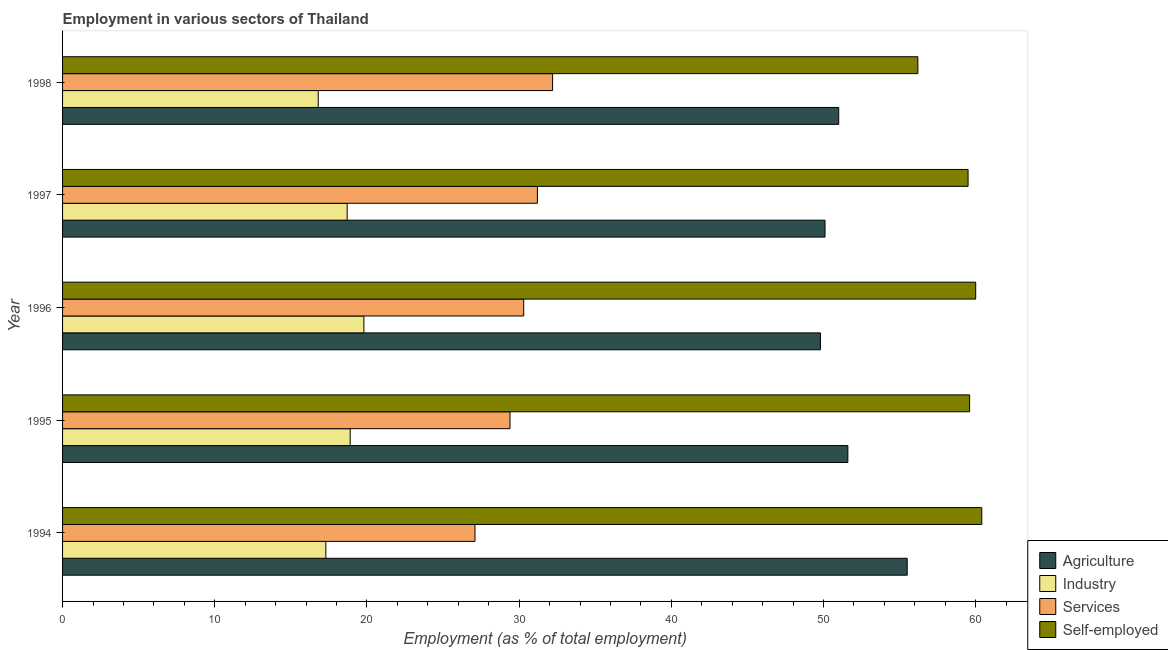Are the number of bars per tick equal to the number of legend labels?
Your answer should be very brief. Yes. Are the number of bars on each tick of the Y-axis equal?
Provide a short and direct response. Yes. How many bars are there on the 2nd tick from the top?
Your answer should be very brief. 4. How many bars are there on the 4th tick from the bottom?
Give a very brief answer. 4. What is the percentage of workers in agriculture in 1996?
Provide a short and direct response. 49.8. Across all years, what is the maximum percentage of self employed workers?
Offer a terse response. 60.4. Across all years, what is the minimum percentage of self employed workers?
Your answer should be very brief. 56.2. In which year was the percentage of workers in industry maximum?
Offer a very short reply. 1996. What is the total percentage of workers in services in the graph?
Offer a terse response. 150.2. What is the difference between the percentage of workers in agriculture in 1994 and that in 1995?
Provide a short and direct response. 3.9. What is the difference between the percentage of workers in agriculture in 1995 and the percentage of self employed workers in 1998?
Your response must be concise. -4.6. In the year 1994, what is the difference between the percentage of workers in agriculture and percentage of self employed workers?
Keep it short and to the point. -4.9. Is the percentage of self employed workers in 1996 less than that in 1998?
Your answer should be very brief. No. What is the difference between the highest and the second highest percentage of workers in agriculture?
Ensure brevity in your answer.  3.9. What is the difference between the highest and the lowest percentage of workers in agriculture?
Offer a terse response. 5.7. In how many years, is the percentage of workers in industry greater than the average percentage of workers in industry taken over all years?
Make the answer very short. 3. Is it the case that in every year, the sum of the percentage of workers in agriculture and percentage of workers in industry is greater than the sum of percentage of self employed workers and percentage of workers in services?
Your answer should be very brief. No. What does the 3rd bar from the top in 1995 represents?
Provide a short and direct response. Industry. What does the 4th bar from the bottom in 1998 represents?
Provide a short and direct response. Self-employed. How many bars are there?
Keep it short and to the point. 20. How many years are there in the graph?
Provide a succinct answer. 5. What is the difference between two consecutive major ticks on the X-axis?
Your answer should be very brief. 10. Are the values on the major ticks of X-axis written in scientific E-notation?
Offer a very short reply. No. Does the graph contain any zero values?
Your answer should be compact. No. Where does the legend appear in the graph?
Your answer should be compact. Bottom right. How many legend labels are there?
Keep it short and to the point. 4. How are the legend labels stacked?
Your answer should be very brief. Vertical. What is the title of the graph?
Offer a terse response. Employment in various sectors of Thailand. Does "Other greenhouse gases" appear as one of the legend labels in the graph?
Your response must be concise. No. What is the label or title of the X-axis?
Your response must be concise. Employment (as % of total employment). What is the label or title of the Y-axis?
Your answer should be compact. Year. What is the Employment (as % of total employment) of Agriculture in 1994?
Your answer should be compact. 55.5. What is the Employment (as % of total employment) of Industry in 1994?
Your answer should be compact. 17.3. What is the Employment (as % of total employment) of Services in 1994?
Your response must be concise. 27.1. What is the Employment (as % of total employment) in Self-employed in 1994?
Your answer should be compact. 60.4. What is the Employment (as % of total employment) in Agriculture in 1995?
Your answer should be very brief. 51.6. What is the Employment (as % of total employment) of Industry in 1995?
Your answer should be compact. 18.9. What is the Employment (as % of total employment) of Services in 1995?
Provide a succinct answer. 29.4. What is the Employment (as % of total employment) in Self-employed in 1995?
Keep it short and to the point. 59.6. What is the Employment (as % of total employment) in Agriculture in 1996?
Keep it short and to the point. 49.8. What is the Employment (as % of total employment) in Industry in 1996?
Provide a succinct answer. 19.8. What is the Employment (as % of total employment) in Services in 1996?
Ensure brevity in your answer.  30.3. What is the Employment (as % of total employment) of Self-employed in 1996?
Your answer should be very brief. 60. What is the Employment (as % of total employment) in Agriculture in 1997?
Provide a short and direct response. 50.1. What is the Employment (as % of total employment) in Industry in 1997?
Make the answer very short. 18.7. What is the Employment (as % of total employment) of Services in 1997?
Ensure brevity in your answer.  31.2. What is the Employment (as % of total employment) of Self-employed in 1997?
Your answer should be compact. 59.5. What is the Employment (as % of total employment) in Agriculture in 1998?
Your response must be concise. 51. What is the Employment (as % of total employment) in Industry in 1998?
Provide a short and direct response. 16.8. What is the Employment (as % of total employment) in Services in 1998?
Ensure brevity in your answer.  32.2. What is the Employment (as % of total employment) in Self-employed in 1998?
Ensure brevity in your answer.  56.2. Across all years, what is the maximum Employment (as % of total employment) in Agriculture?
Give a very brief answer. 55.5. Across all years, what is the maximum Employment (as % of total employment) in Industry?
Ensure brevity in your answer.  19.8. Across all years, what is the maximum Employment (as % of total employment) in Services?
Offer a terse response. 32.2. Across all years, what is the maximum Employment (as % of total employment) of Self-employed?
Give a very brief answer. 60.4. Across all years, what is the minimum Employment (as % of total employment) in Agriculture?
Provide a succinct answer. 49.8. Across all years, what is the minimum Employment (as % of total employment) in Industry?
Your answer should be very brief. 16.8. Across all years, what is the minimum Employment (as % of total employment) of Services?
Make the answer very short. 27.1. Across all years, what is the minimum Employment (as % of total employment) in Self-employed?
Your response must be concise. 56.2. What is the total Employment (as % of total employment) in Agriculture in the graph?
Your response must be concise. 258. What is the total Employment (as % of total employment) of Industry in the graph?
Give a very brief answer. 91.5. What is the total Employment (as % of total employment) of Services in the graph?
Give a very brief answer. 150.2. What is the total Employment (as % of total employment) of Self-employed in the graph?
Provide a short and direct response. 295.7. What is the difference between the Employment (as % of total employment) in Industry in 1994 and that in 1995?
Provide a short and direct response. -1.6. What is the difference between the Employment (as % of total employment) in Agriculture in 1994 and that in 1996?
Your answer should be compact. 5.7. What is the difference between the Employment (as % of total employment) of Industry in 1994 and that in 1996?
Your response must be concise. -2.5. What is the difference between the Employment (as % of total employment) in Industry in 1994 and that in 1997?
Give a very brief answer. -1.4. What is the difference between the Employment (as % of total employment) of Agriculture in 1994 and that in 1998?
Make the answer very short. 4.5. What is the difference between the Employment (as % of total employment) of Self-employed in 1994 and that in 1998?
Your answer should be very brief. 4.2. What is the difference between the Employment (as % of total employment) of Services in 1995 and that in 1996?
Make the answer very short. -0.9. What is the difference between the Employment (as % of total employment) in Self-employed in 1995 and that in 1996?
Provide a short and direct response. -0.4. What is the difference between the Employment (as % of total employment) of Agriculture in 1995 and that in 1997?
Provide a succinct answer. 1.5. What is the difference between the Employment (as % of total employment) of Services in 1995 and that in 1997?
Offer a terse response. -1.8. What is the difference between the Employment (as % of total employment) of Industry in 1996 and that in 1997?
Ensure brevity in your answer.  1.1. What is the difference between the Employment (as % of total employment) in Self-employed in 1996 and that in 1997?
Give a very brief answer. 0.5. What is the difference between the Employment (as % of total employment) in Agriculture in 1996 and that in 1998?
Offer a very short reply. -1.2. What is the difference between the Employment (as % of total employment) in Self-employed in 1996 and that in 1998?
Offer a terse response. 3.8. What is the difference between the Employment (as % of total employment) in Agriculture in 1997 and that in 1998?
Give a very brief answer. -0.9. What is the difference between the Employment (as % of total employment) in Industry in 1997 and that in 1998?
Keep it short and to the point. 1.9. What is the difference between the Employment (as % of total employment) of Services in 1997 and that in 1998?
Keep it short and to the point. -1. What is the difference between the Employment (as % of total employment) of Self-employed in 1997 and that in 1998?
Offer a very short reply. 3.3. What is the difference between the Employment (as % of total employment) of Agriculture in 1994 and the Employment (as % of total employment) of Industry in 1995?
Ensure brevity in your answer.  36.6. What is the difference between the Employment (as % of total employment) of Agriculture in 1994 and the Employment (as % of total employment) of Services in 1995?
Make the answer very short. 26.1. What is the difference between the Employment (as % of total employment) of Agriculture in 1994 and the Employment (as % of total employment) of Self-employed in 1995?
Your response must be concise. -4.1. What is the difference between the Employment (as % of total employment) in Industry in 1994 and the Employment (as % of total employment) in Self-employed in 1995?
Provide a short and direct response. -42.3. What is the difference between the Employment (as % of total employment) in Services in 1994 and the Employment (as % of total employment) in Self-employed in 1995?
Make the answer very short. -32.5. What is the difference between the Employment (as % of total employment) of Agriculture in 1994 and the Employment (as % of total employment) of Industry in 1996?
Ensure brevity in your answer.  35.7. What is the difference between the Employment (as % of total employment) of Agriculture in 1994 and the Employment (as % of total employment) of Services in 1996?
Keep it short and to the point. 25.2. What is the difference between the Employment (as % of total employment) of Industry in 1994 and the Employment (as % of total employment) of Self-employed in 1996?
Make the answer very short. -42.7. What is the difference between the Employment (as % of total employment) in Services in 1994 and the Employment (as % of total employment) in Self-employed in 1996?
Offer a very short reply. -32.9. What is the difference between the Employment (as % of total employment) in Agriculture in 1994 and the Employment (as % of total employment) in Industry in 1997?
Your answer should be compact. 36.8. What is the difference between the Employment (as % of total employment) in Agriculture in 1994 and the Employment (as % of total employment) in Services in 1997?
Offer a very short reply. 24.3. What is the difference between the Employment (as % of total employment) in Industry in 1994 and the Employment (as % of total employment) in Self-employed in 1997?
Provide a short and direct response. -42.2. What is the difference between the Employment (as % of total employment) in Services in 1994 and the Employment (as % of total employment) in Self-employed in 1997?
Your answer should be very brief. -32.4. What is the difference between the Employment (as % of total employment) of Agriculture in 1994 and the Employment (as % of total employment) of Industry in 1998?
Keep it short and to the point. 38.7. What is the difference between the Employment (as % of total employment) of Agriculture in 1994 and the Employment (as % of total employment) of Services in 1998?
Provide a succinct answer. 23.3. What is the difference between the Employment (as % of total employment) in Agriculture in 1994 and the Employment (as % of total employment) in Self-employed in 1998?
Offer a terse response. -0.7. What is the difference between the Employment (as % of total employment) in Industry in 1994 and the Employment (as % of total employment) in Services in 1998?
Make the answer very short. -14.9. What is the difference between the Employment (as % of total employment) of Industry in 1994 and the Employment (as % of total employment) of Self-employed in 1998?
Your answer should be compact. -38.9. What is the difference between the Employment (as % of total employment) in Services in 1994 and the Employment (as % of total employment) in Self-employed in 1998?
Provide a short and direct response. -29.1. What is the difference between the Employment (as % of total employment) of Agriculture in 1995 and the Employment (as % of total employment) of Industry in 1996?
Make the answer very short. 31.8. What is the difference between the Employment (as % of total employment) of Agriculture in 1995 and the Employment (as % of total employment) of Services in 1996?
Your answer should be very brief. 21.3. What is the difference between the Employment (as % of total employment) in Agriculture in 1995 and the Employment (as % of total employment) in Self-employed in 1996?
Your answer should be compact. -8.4. What is the difference between the Employment (as % of total employment) in Industry in 1995 and the Employment (as % of total employment) in Self-employed in 1996?
Offer a terse response. -41.1. What is the difference between the Employment (as % of total employment) in Services in 1995 and the Employment (as % of total employment) in Self-employed in 1996?
Offer a terse response. -30.6. What is the difference between the Employment (as % of total employment) in Agriculture in 1995 and the Employment (as % of total employment) in Industry in 1997?
Ensure brevity in your answer.  32.9. What is the difference between the Employment (as % of total employment) in Agriculture in 1995 and the Employment (as % of total employment) in Services in 1997?
Offer a terse response. 20.4. What is the difference between the Employment (as % of total employment) of Agriculture in 1995 and the Employment (as % of total employment) of Self-employed in 1997?
Your response must be concise. -7.9. What is the difference between the Employment (as % of total employment) in Industry in 1995 and the Employment (as % of total employment) in Self-employed in 1997?
Your answer should be very brief. -40.6. What is the difference between the Employment (as % of total employment) in Services in 1995 and the Employment (as % of total employment) in Self-employed in 1997?
Ensure brevity in your answer.  -30.1. What is the difference between the Employment (as % of total employment) of Agriculture in 1995 and the Employment (as % of total employment) of Industry in 1998?
Ensure brevity in your answer.  34.8. What is the difference between the Employment (as % of total employment) in Agriculture in 1995 and the Employment (as % of total employment) in Services in 1998?
Offer a terse response. 19.4. What is the difference between the Employment (as % of total employment) in Industry in 1995 and the Employment (as % of total employment) in Self-employed in 1998?
Offer a very short reply. -37.3. What is the difference between the Employment (as % of total employment) of Services in 1995 and the Employment (as % of total employment) of Self-employed in 1998?
Offer a terse response. -26.8. What is the difference between the Employment (as % of total employment) of Agriculture in 1996 and the Employment (as % of total employment) of Industry in 1997?
Your answer should be very brief. 31.1. What is the difference between the Employment (as % of total employment) in Agriculture in 1996 and the Employment (as % of total employment) in Services in 1997?
Keep it short and to the point. 18.6. What is the difference between the Employment (as % of total employment) in Agriculture in 1996 and the Employment (as % of total employment) in Self-employed in 1997?
Your response must be concise. -9.7. What is the difference between the Employment (as % of total employment) in Industry in 1996 and the Employment (as % of total employment) in Services in 1997?
Make the answer very short. -11.4. What is the difference between the Employment (as % of total employment) of Industry in 1996 and the Employment (as % of total employment) of Self-employed in 1997?
Provide a short and direct response. -39.7. What is the difference between the Employment (as % of total employment) in Services in 1996 and the Employment (as % of total employment) in Self-employed in 1997?
Your response must be concise. -29.2. What is the difference between the Employment (as % of total employment) of Agriculture in 1996 and the Employment (as % of total employment) of Industry in 1998?
Make the answer very short. 33. What is the difference between the Employment (as % of total employment) of Industry in 1996 and the Employment (as % of total employment) of Self-employed in 1998?
Make the answer very short. -36.4. What is the difference between the Employment (as % of total employment) in Services in 1996 and the Employment (as % of total employment) in Self-employed in 1998?
Your answer should be compact. -25.9. What is the difference between the Employment (as % of total employment) in Agriculture in 1997 and the Employment (as % of total employment) in Industry in 1998?
Make the answer very short. 33.3. What is the difference between the Employment (as % of total employment) of Industry in 1997 and the Employment (as % of total employment) of Services in 1998?
Offer a very short reply. -13.5. What is the difference between the Employment (as % of total employment) of Industry in 1997 and the Employment (as % of total employment) of Self-employed in 1998?
Your answer should be compact. -37.5. What is the difference between the Employment (as % of total employment) in Services in 1997 and the Employment (as % of total employment) in Self-employed in 1998?
Provide a short and direct response. -25. What is the average Employment (as % of total employment) of Agriculture per year?
Offer a very short reply. 51.6. What is the average Employment (as % of total employment) in Industry per year?
Offer a terse response. 18.3. What is the average Employment (as % of total employment) in Services per year?
Keep it short and to the point. 30.04. What is the average Employment (as % of total employment) of Self-employed per year?
Your answer should be compact. 59.14. In the year 1994, what is the difference between the Employment (as % of total employment) of Agriculture and Employment (as % of total employment) of Industry?
Provide a succinct answer. 38.2. In the year 1994, what is the difference between the Employment (as % of total employment) of Agriculture and Employment (as % of total employment) of Services?
Provide a short and direct response. 28.4. In the year 1994, what is the difference between the Employment (as % of total employment) in Agriculture and Employment (as % of total employment) in Self-employed?
Give a very brief answer. -4.9. In the year 1994, what is the difference between the Employment (as % of total employment) in Industry and Employment (as % of total employment) in Self-employed?
Ensure brevity in your answer.  -43.1. In the year 1994, what is the difference between the Employment (as % of total employment) in Services and Employment (as % of total employment) in Self-employed?
Your response must be concise. -33.3. In the year 1995, what is the difference between the Employment (as % of total employment) of Agriculture and Employment (as % of total employment) of Industry?
Offer a terse response. 32.7. In the year 1995, what is the difference between the Employment (as % of total employment) of Agriculture and Employment (as % of total employment) of Self-employed?
Give a very brief answer. -8. In the year 1995, what is the difference between the Employment (as % of total employment) of Industry and Employment (as % of total employment) of Services?
Your response must be concise. -10.5. In the year 1995, what is the difference between the Employment (as % of total employment) of Industry and Employment (as % of total employment) of Self-employed?
Your answer should be very brief. -40.7. In the year 1995, what is the difference between the Employment (as % of total employment) in Services and Employment (as % of total employment) in Self-employed?
Ensure brevity in your answer.  -30.2. In the year 1996, what is the difference between the Employment (as % of total employment) of Agriculture and Employment (as % of total employment) of Services?
Give a very brief answer. 19.5. In the year 1996, what is the difference between the Employment (as % of total employment) in Industry and Employment (as % of total employment) in Services?
Make the answer very short. -10.5. In the year 1996, what is the difference between the Employment (as % of total employment) of Industry and Employment (as % of total employment) of Self-employed?
Provide a succinct answer. -40.2. In the year 1996, what is the difference between the Employment (as % of total employment) in Services and Employment (as % of total employment) in Self-employed?
Your response must be concise. -29.7. In the year 1997, what is the difference between the Employment (as % of total employment) of Agriculture and Employment (as % of total employment) of Industry?
Your response must be concise. 31.4. In the year 1997, what is the difference between the Employment (as % of total employment) in Industry and Employment (as % of total employment) in Services?
Offer a very short reply. -12.5. In the year 1997, what is the difference between the Employment (as % of total employment) of Industry and Employment (as % of total employment) of Self-employed?
Ensure brevity in your answer.  -40.8. In the year 1997, what is the difference between the Employment (as % of total employment) in Services and Employment (as % of total employment) in Self-employed?
Keep it short and to the point. -28.3. In the year 1998, what is the difference between the Employment (as % of total employment) in Agriculture and Employment (as % of total employment) in Industry?
Offer a terse response. 34.2. In the year 1998, what is the difference between the Employment (as % of total employment) in Agriculture and Employment (as % of total employment) in Services?
Offer a very short reply. 18.8. In the year 1998, what is the difference between the Employment (as % of total employment) in Agriculture and Employment (as % of total employment) in Self-employed?
Offer a terse response. -5.2. In the year 1998, what is the difference between the Employment (as % of total employment) in Industry and Employment (as % of total employment) in Services?
Keep it short and to the point. -15.4. In the year 1998, what is the difference between the Employment (as % of total employment) of Industry and Employment (as % of total employment) of Self-employed?
Keep it short and to the point. -39.4. What is the ratio of the Employment (as % of total employment) in Agriculture in 1994 to that in 1995?
Offer a terse response. 1.08. What is the ratio of the Employment (as % of total employment) of Industry in 1994 to that in 1995?
Offer a very short reply. 0.92. What is the ratio of the Employment (as % of total employment) in Services in 1994 to that in 1995?
Make the answer very short. 0.92. What is the ratio of the Employment (as % of total employment) of Self-employed in 1994 to that in 1995?
Offer a very short reply. 1.01. What is the ratio of the Employment (as % of total employment) of Agriculture in 1994 to that in 1996?
Ensure brevity in your answer.  1.11. What is the ratio of the Employment (as % of total employment) in Industry in 1994 to that in 1996?
Your response must be concise. 0.87. What is the ratio of the Employment (as % of total employment) in Services in 1994 to that in 1996?
Keep it short and to the point. 0.89. What is the ratio of the Employment (as % of total employment) in Self-employed in 1994 to that in 1996?
Make the answer very short. 1.01. What is the ratio of the Employment (as % of total employment) of Agriculture in 1994 to that in 1997?
Ensure brevity in your answer.  1.11. What is the ratio of the Employment (as % of total employment) of Industry in 1994 to that in 1997?
Provide a short and direct response. 0.93. What is the ratio of the Employment (as % of total employment) of Services in 1994 to that in 1997?
Offer a terse response. 0.87. What is the ratio of the Employment (as % of total employment) in Self-employed in 1994 to that in 1997?
Provide a succinct answer. 1.02. What is the ratio of the Employment (as % of total employment) of Agriculture in 1994 to that in 1998?
Your response must be concise. 1.09. What is the ratio of the Employment (as % of total employment) in Industry in 1994 to that in 1998?
Keep it short and to the point. 1.03. What is the ratio of the Employment (as % of total employment) in Services in 1994 to that in 1998?
Keep it short and to the point. 0.84. What is the ratio of the Employment (as % of total employment) in Self-employed in 1994 to that in 1998?
Provide a short and direct response. 1.07. What is the ratio of the Employment (as % of total employment) of Agriculture in 1995 to that in 1996?
Provide a short and direct response. 1.04. What is the ratio of the Employment (as % of total employment) in Industry in 1995 to that in 1996?
Give a very brief answer. 0.95. What is the ratio of the Employment (as % of total employment) in Services in 1995 to that in 1996?
Your answer should be compact. 0.97. What is the ratio of the Employment (as % of total employment) in Self-employed in 1995 to that in 1996?
Ensure brevity in your answer.  0.99. What is the ratio of the Employment (as % of total employment) in Agriculture in 1995 to that in 1997?
Offer a terse response. 1.03. What is the ratio of the Employment (as % of total employment) in Industry in 1995 to that in 1997?
Provide a short and direct response. 1.01. What is the ratio of the Employment (as % of total employment) of Services in 1995 to that in 1997?
Ensure brevity in your answer.  0.94. What is the ratio of the Employment (as % of total employment) in Agriculture in 1995 to that in 1998?
Your answer should be compact. 1.01. What is the ratio of the Employment (as % of total employment) of Industry in 1995 to that in 1998?
Your response must be concise. 1.12. What is the ratio of the Employment (as % of total employment) in Services in 1995 to that in 1998?
Offer a very short reply. 0.91. What is the ratio of the Employment (as % of total employment) in Self-employed in 1995 to that in 1998?
Provide a short and direct response. 1.06. What is the ratio of the Employment (as % of total employment) of Agriculture in 1996 to that in 1997?
Keep it short and to the point. 0.99. What is the ratio of the Employment (as % of total employment) in Industry in 1996 to that in 1997?
Give a very brief answer. 1.06. What is the ratio of the Employment (as % of total employment) of Services in 1996 to that in 1997?
Provide a succinct answer. 0.97. What is the ratio of the Employment (as % of total employment) in Self-employed in 1996 to that in 1997?
Make the answer very short. 1.01. What is the ratio of the Employment (as % of total employment) in Agriculture in 1996 to that in 1998?
Provide a succinct answer. 0.98. What is the ratio of the Employment (as % of total employment) of Industry in 1996 to that in 1998?
Your response must be concise. 1.18. What is the ratio of the Employment (as % of total employment) in Services in 1996 to that in 1998?
Provide a short and direct response. 0.94. What is the ratio of the Employment (as % of total employment) of Self-employed in 1996 to that in 1998?
Your answer should be very brief. 1.07. What is the ratio of the Employment (as % of total employment) of Agriculture in 1997 to that in 1998?
Your answer should be compact. 0.98. What is the ratio of the Employment (as % of total employment) of Industry in 1997 to that in 1998?
Keep it short and to the point. 1.11. What is the ratio of the Employment (as % of total employment) in Services in 1997 to that in 1998?
Give a very brief answer. 0.97. What is the ratio of the Employment (as % of total employment) of Self-employed in 1997 to that in 1998?
Offer a terse response. 1.06. What is the difference between the highest and the second highest Employment (as % of total employment) of Industry?
Provide a succinct answer. 0.9. What is the difference between the highest and the second highest Employment (as % of total employment) of Self-employed?
Keep it short and to the point. 0.4. What is the difference between the highest and the lowest Employment (as % of total employment) in Industry?
Your response must be concise. 3. 